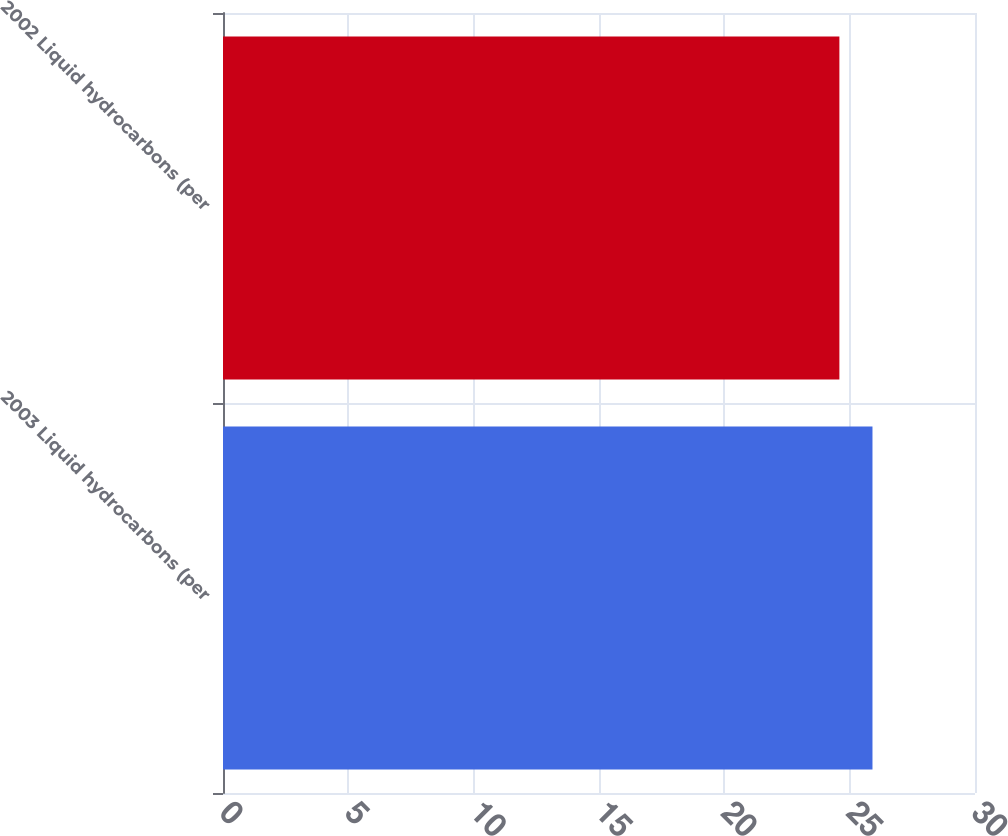<chart> <loc_0><loc_0><loc_500><loc_500><bar_chart><fcel>2003 Liquid hydrocarbons (per<fcel>2002 Liquid hydrocarbons (per<nl><fcel>25.91<fcel>24.59<nl></chart> 